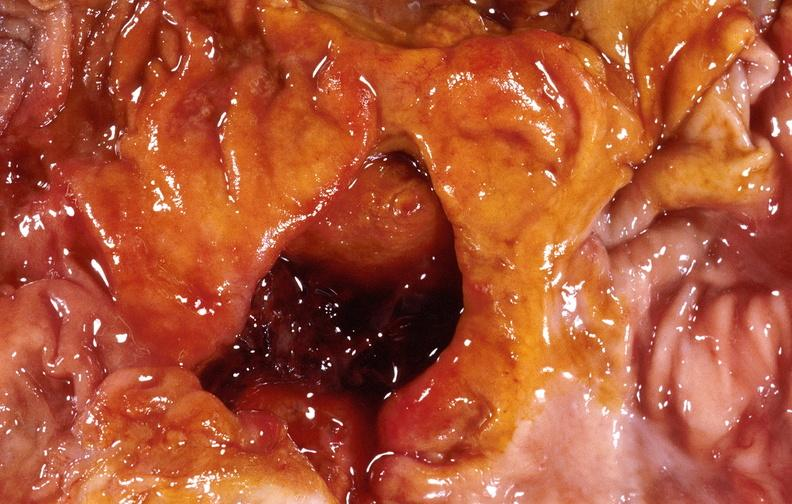s gastrointestinal present?
Answer the question using a single word or phrase. Yes 